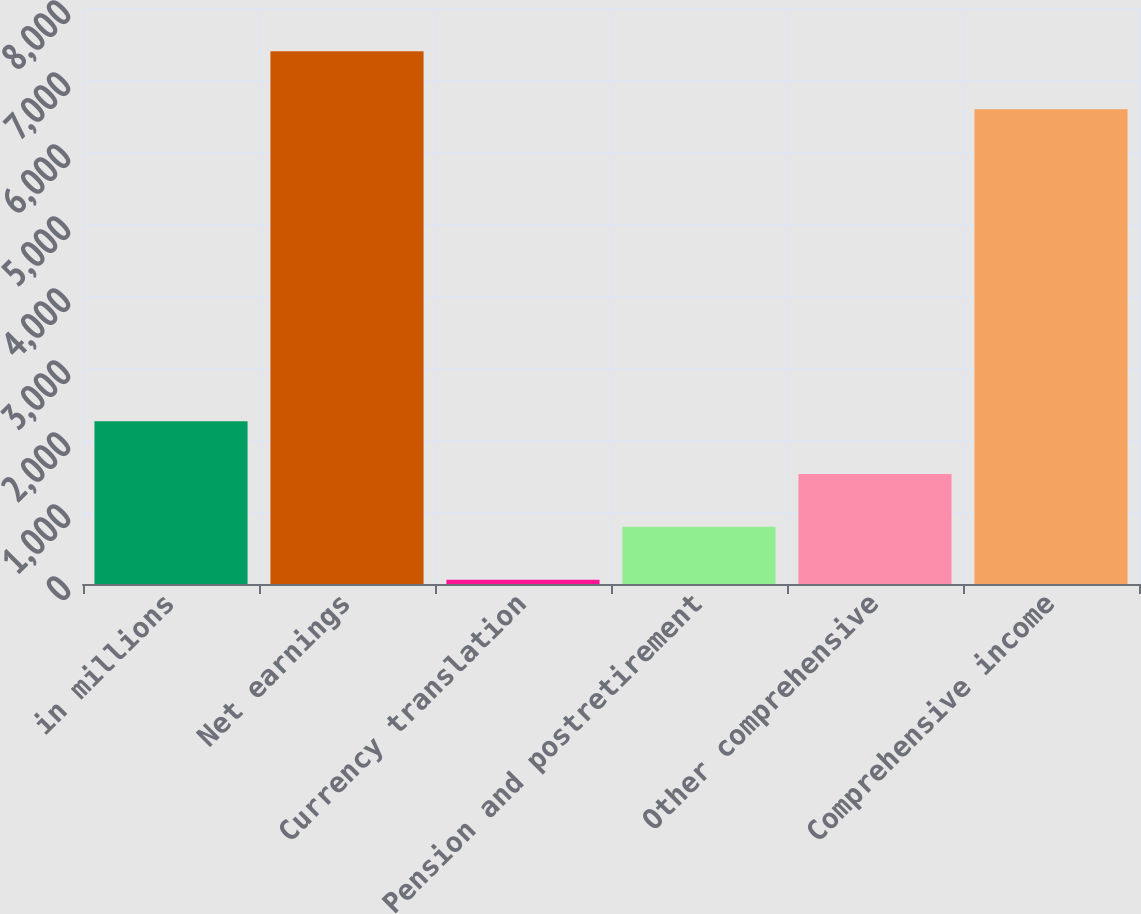Convert chart. <chart><loc_0><loc_0><loc_500><loc_500><bar_chart><fcel>in millions<fcel>Net earnings<fcel>Currency translation<fcel>Pension and postretirement<fcel>Other comprehensive<fcel>Comprehensive income<nl><fcel>2261.4<fcel>7398<fcel>60<fcel>793.8<fcel>1527.6<fcel>6595<nl></chart> 